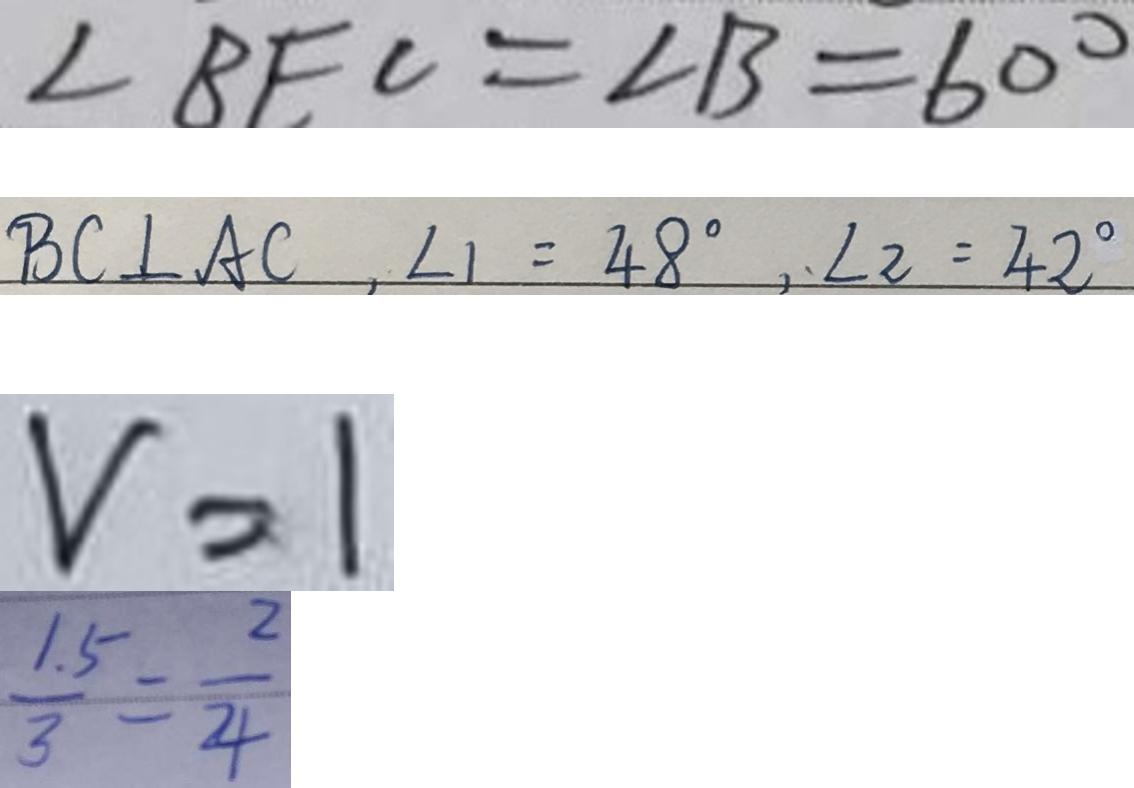Convert formula to latex. <formula><loc_0><loc_0><loc_500><loc_500>\angle B E C = \angle B = 6 0 ^ { \circ } 
 B C \bot A C , \angle 1 = 4 8 ^ { \circ } , \angle 2 = 4 2 ^ { \circ } 
 v = 1 
 \frac { 1 . 5 } { 3 } = \frac { 2 } { 4 }</formula> 